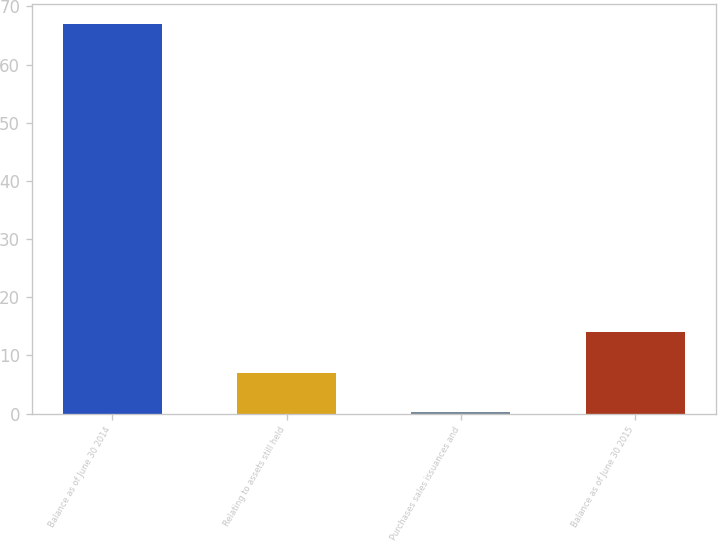Convert chart. <chart><loc_0><loc_0><loc_500><loc_500><bar_chart><fcel>Balance as of June 30 2014<fcel>Relating to assets still held<fcel>Purchases sales issuances and<fcel>Balance as of June 30 2015<nl><fcel>67<fcel>6.97<fcel>0.3<fcel>14<nl></chart> 